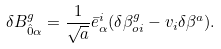Convert formula to latex. <formula><loc_0><loc_0><loc_500><loc_500>\delta B _ { \hat { 0 } \alpha } ^ { g } = \frac { 1 } { \sqrt { a } } \bar { e } _ { \alpha } ^ { i } ( \delta \beta _ { o i } ^ { g } - v _ { i } \delta \beta ^ { a } ) .</formula> 